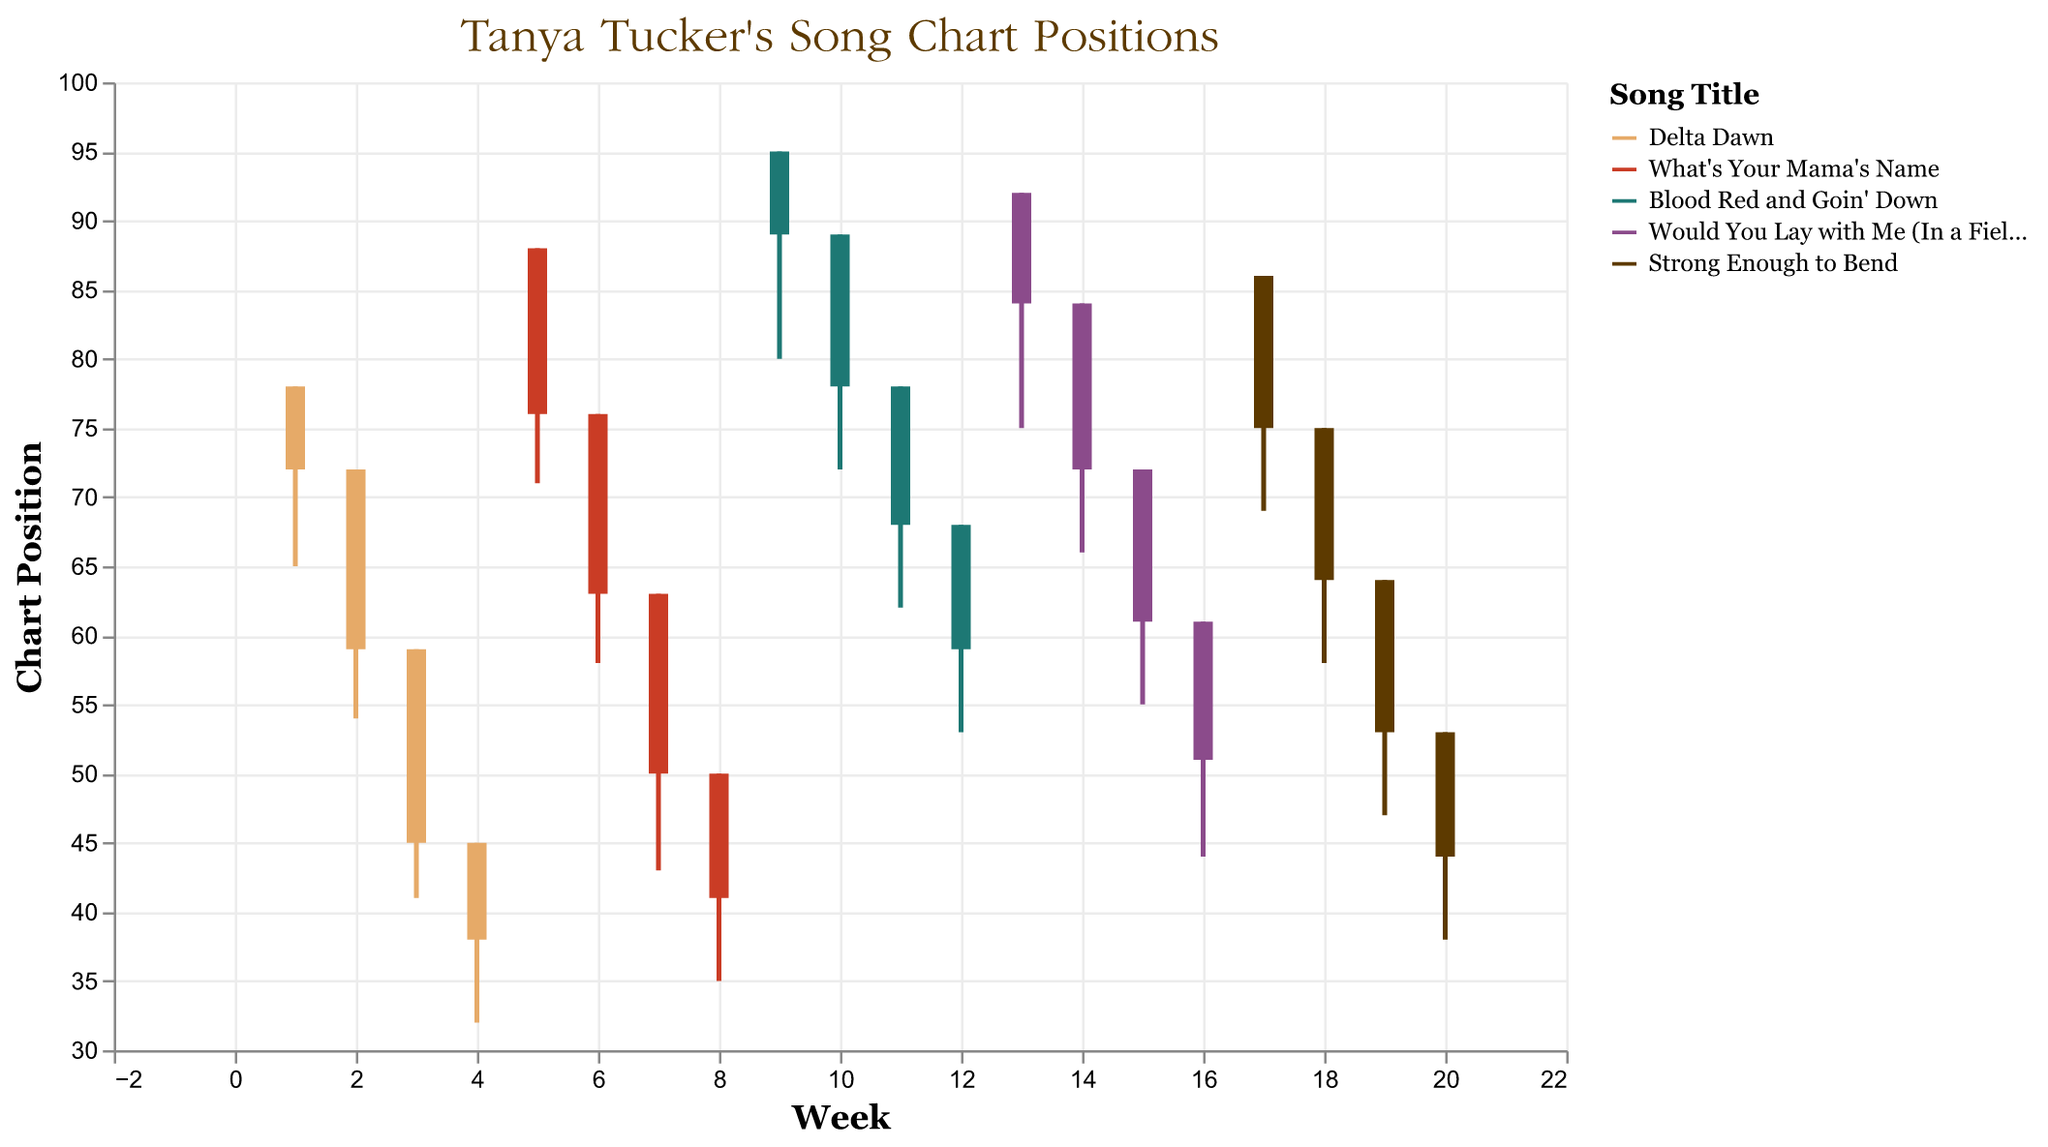What is the title of the chart? The title of the chart is typically found at the top center and it provides overall context or summary. Here, it's "Tanya Tucker's Song Chart Positions".
Answer: Tanya Tucker's Song Chart Positions Which song has the lowest 'Low' chart position in its first week? To find this, identify the lowest value in the 'Low' column for the first week of each song. "Delta Dawn" has a 'Low' value of 78 in its first week. Other songs have higher 'Low' values in their first weeks.
Answer: Delta Dawn What was the closing position of "Delta Dawn" in the second week? Inspect the 'Close' column for "Delta Dawn" in the second week, which is indicated by Week 2. The closing position is 59.
Answer: 59 Which song achieved the highest closing position within four weeks? We need to compare the 'Close' values of each song within Week 1-4, Week 5-8, etc. "Delta Dawn" has the highest closing position, 38, in Week 4.
Answer: Delta Dawn How many songs were tracked in this chart? Count the unique song titles. There are 5 unique song titles: "Delta Dawn", "What's Your Mama's Name", "Blood Red and Goin' Down", "Would You Lay with Me (In a Field of Stone)", and "Strong Enough to Bend".
Answer: 5 In which week did "Blood Red and Goin' Down" have its lowest chart position? Look at the 'Low' values for "Blood Red and Goin' Down" across its weeks (Week 9-12). The lowest value is 53 in the 12th week.
Answer: Week 12 Which song showed the biggest drop in its 'Open' to 'Close' position in any week? Calculate the difference between 'Open' and 'Close' for each entry. "Delta Dawn" in Week 3 had a drop from 59 to 45, which is a 14-point drop.
Answer: Delta Dawn How does the opening position of "Would You Lay with Me (In a Field of Stone)" evolve over the weeks? Check the 'Open' values over Week 13-16. It starts at 92 and gradually decreases: Week 13: 92, Week 14: 84, Week 15: 72, Week 16: 61.
Answer: Decreases from 92 to 61 Which song reached the highest 'High' position and what was it? Identify the highest value in the 'High' column. "What's Your Mama's Name" reached a 'High' of 35 in Week 8. Other songs have higher values.
Answer: What's Your Mama's Name What trend do you observe in the first four weeks of "Strong Enough to Bend"? Observe the 'Open', 'High', 'Low', and 'Close' for "Strong Enough to Bend" from Week 17-20. The chart positions generally decrease over time.
Answer: Decreasing trend 